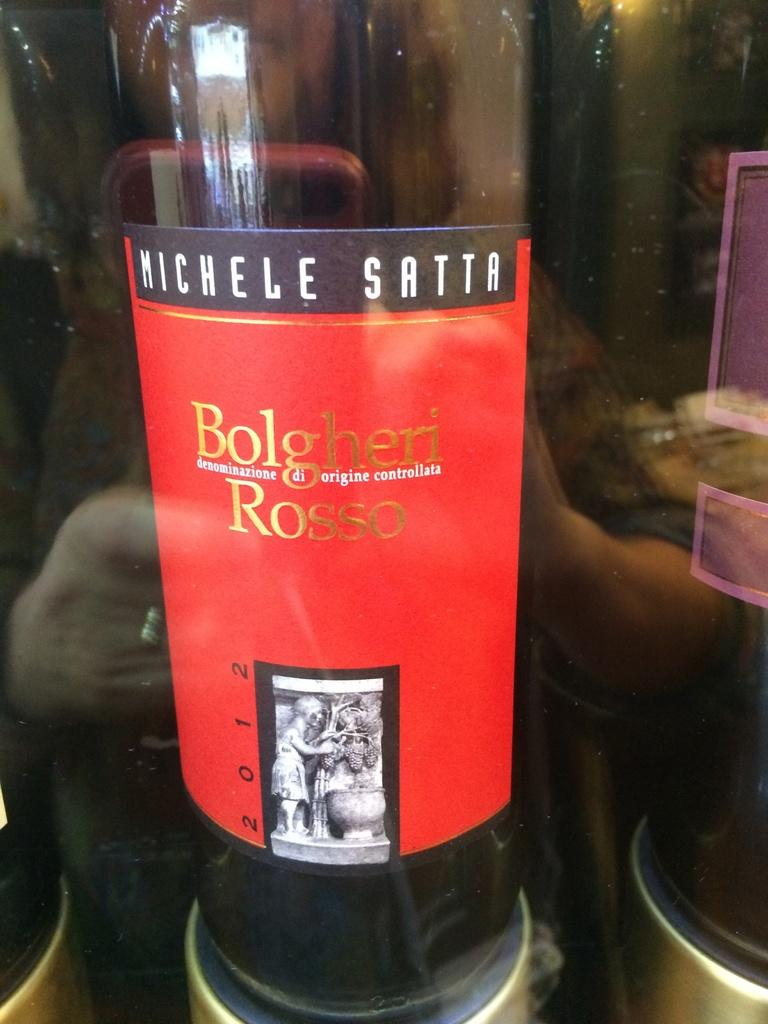<image>
Describe the image concisely. A bottle of wine on a display called Michele Satta. 